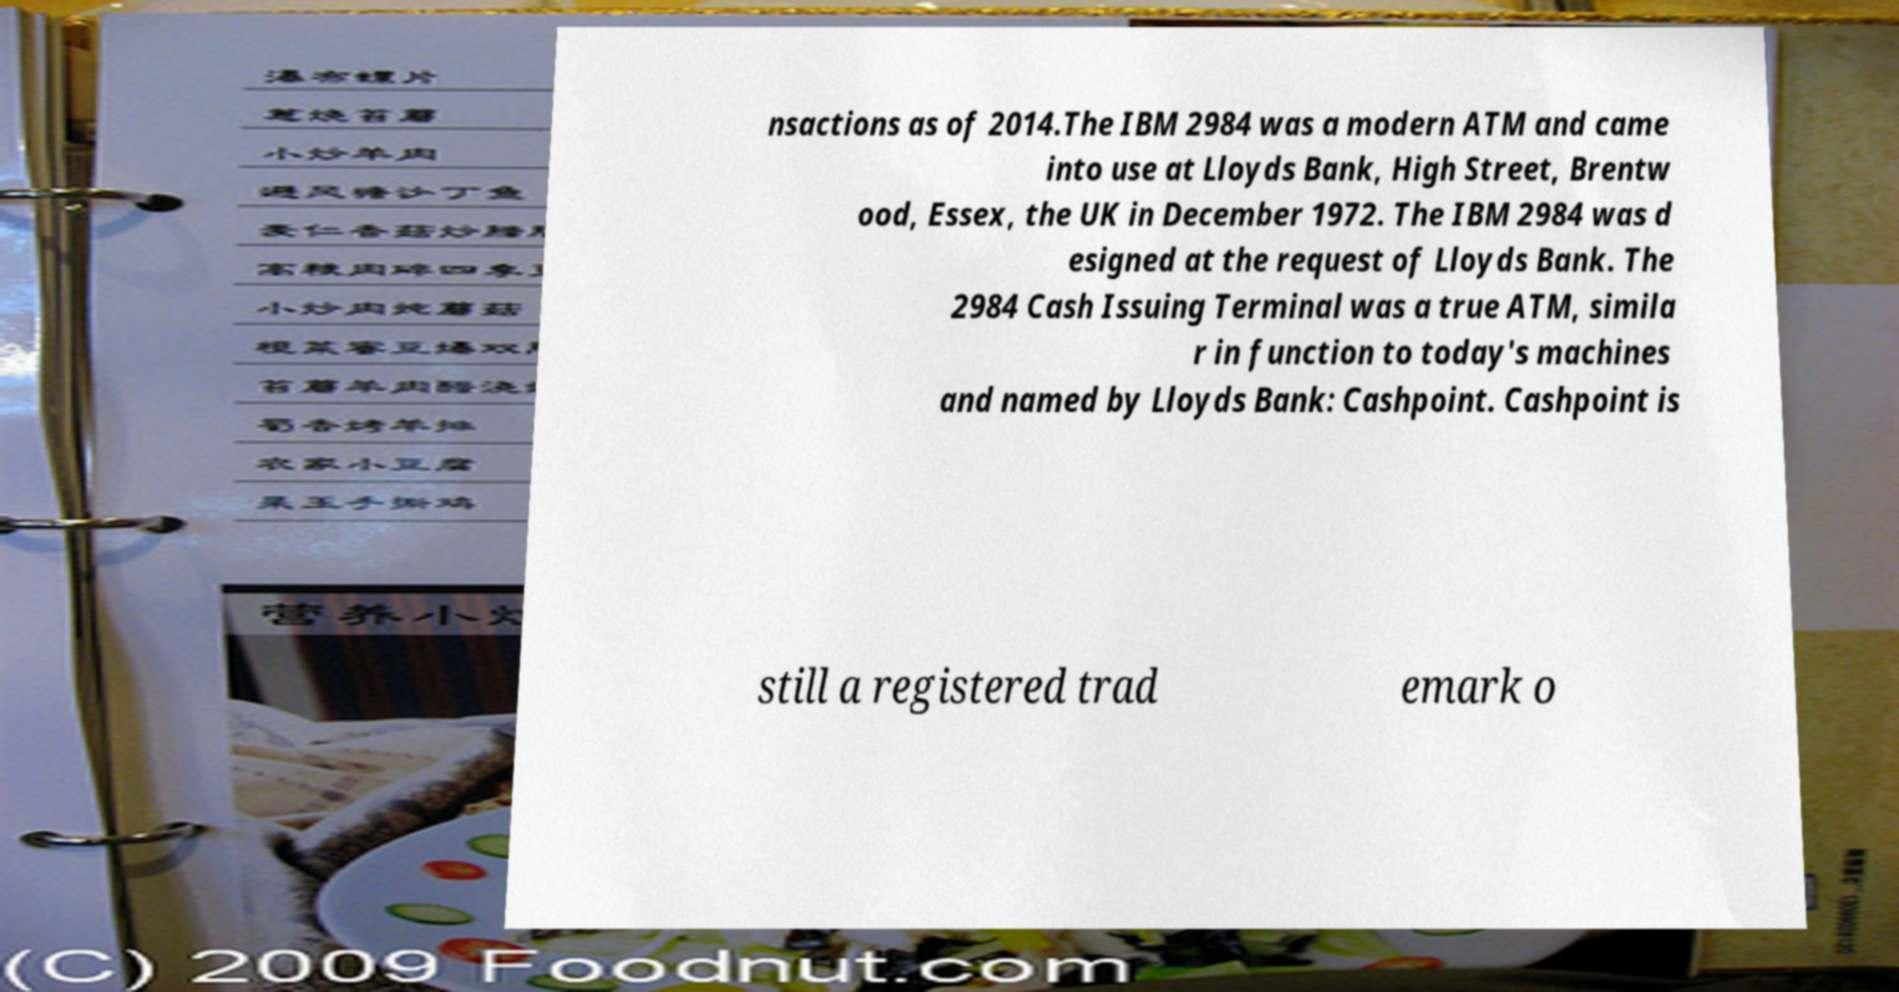Can you accurately transcribe the text from the provided image for me? nsactions as of 2014.The IBM 2984 was a modern ATM and came into use at Lloyds Bank, High Street, Brentw ood, Essex, the UK in December 1972. The IBM 2984 was d esigned at the request of Lloyds Bank. The 2984 Cash Issuing Terminal was a true ATM, simila r in function to today's machines and named by Lloyds Bank: Cashpoint. Cashpoint is still a registered trad emark o 